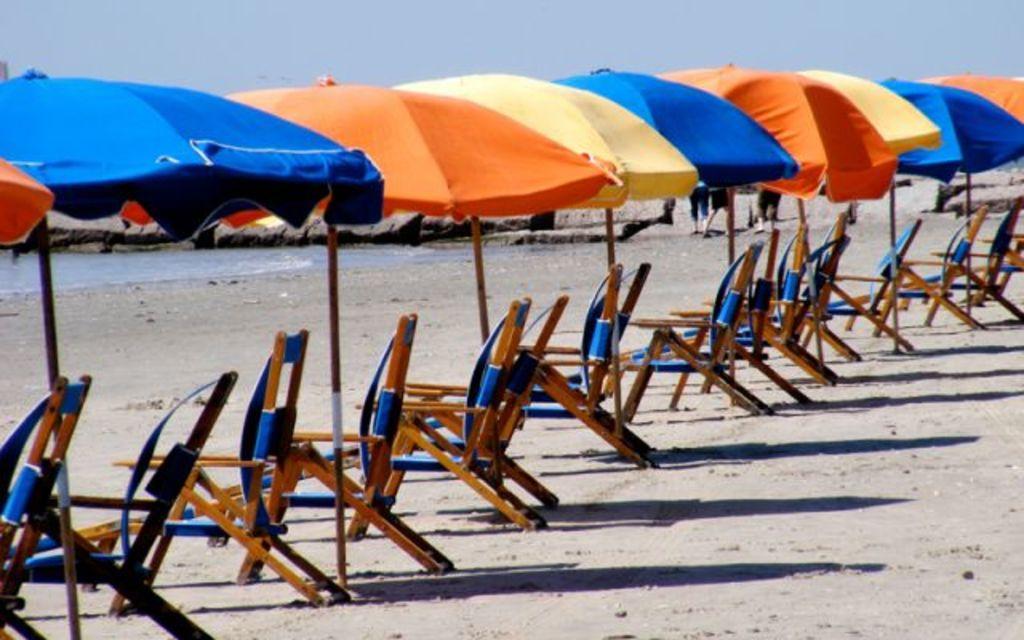Please provide a concise description of this image. In this image we can see many chairs and umbrellas. In the background there is water and rocks. And also there is sky. 